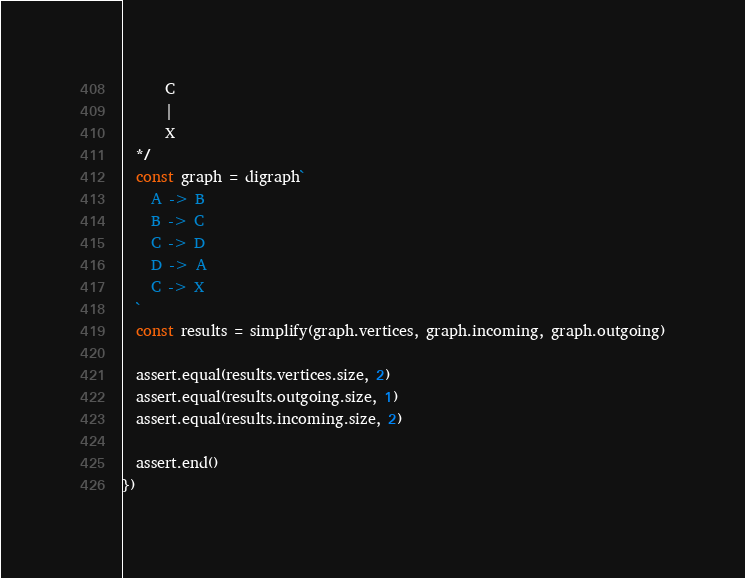<code> <loc_0><loc_0><loc_500><loc_500><_JavaScript_>      C
      |
      X
  */
  const graph = digraph`
    A -> B
    B -> C
    C -> D
    D -> A
    C -> X
  `
  const results = simplify(graph.vertices, graph.incoming, graph.outgoing)

  assert.equal(results.vertices.size, 2)
  assert.equal(results.outgoing.size, 1)
  assert.equal(results.incoming.size, 2)

  assert.end()
})
</code> 